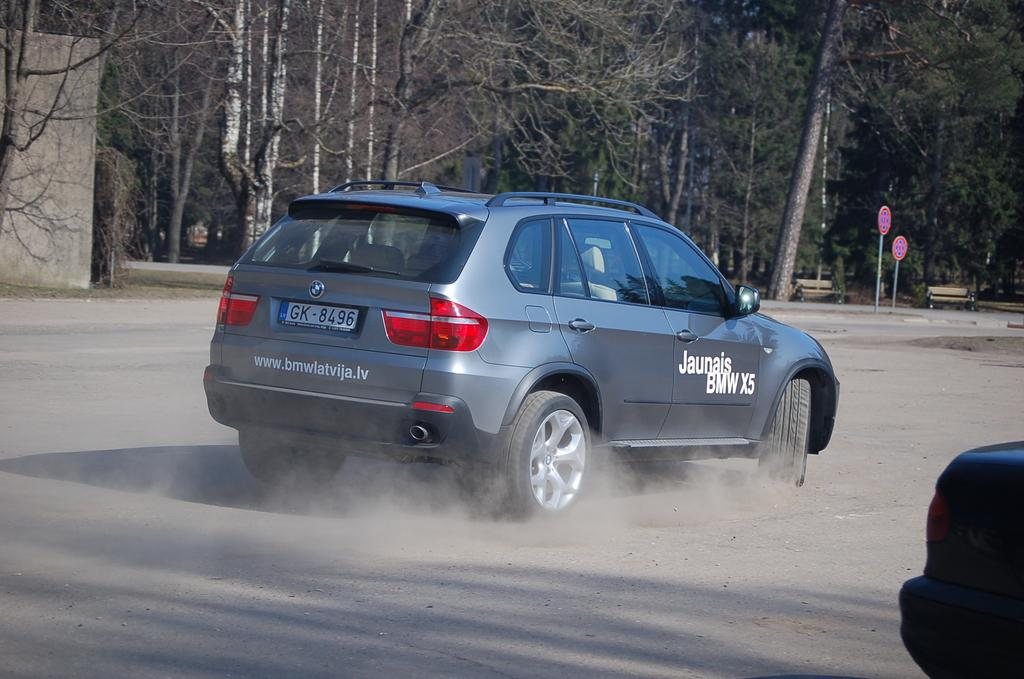<image>
Render a clear and concise summary of the photo. A silver vehicle says Jaunais BMW X5 on its side. 